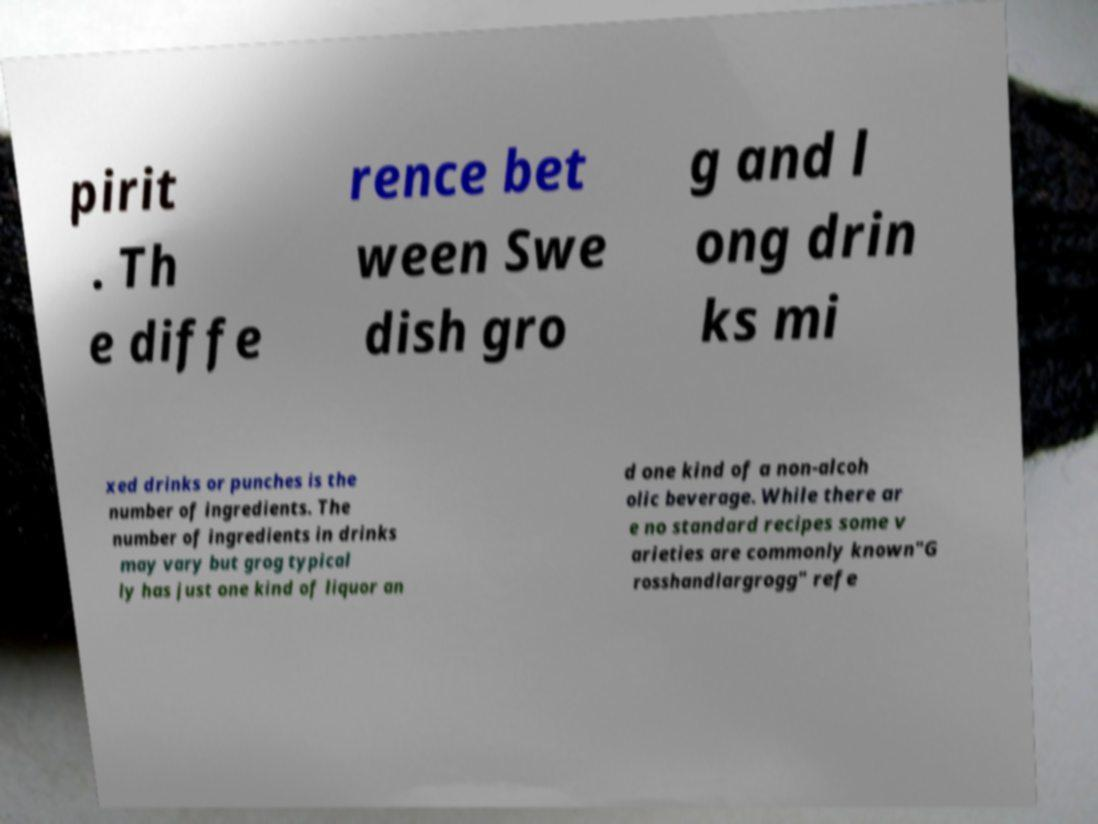Can you accurately transcribe the text from the provided image for me? pirit . Th e diffe rence bet ween Swe dish gro g and l ong drin ks mi xed drinks or punches is the number of ingredients. The number of ingredients in drinks may vary but grog typical ly has just one kind of liquor an d one kind of a non-alcoh olic beverage. While there ar e no standard recipes some v arieties are commonly known"G rosshandlargrogg" refe 